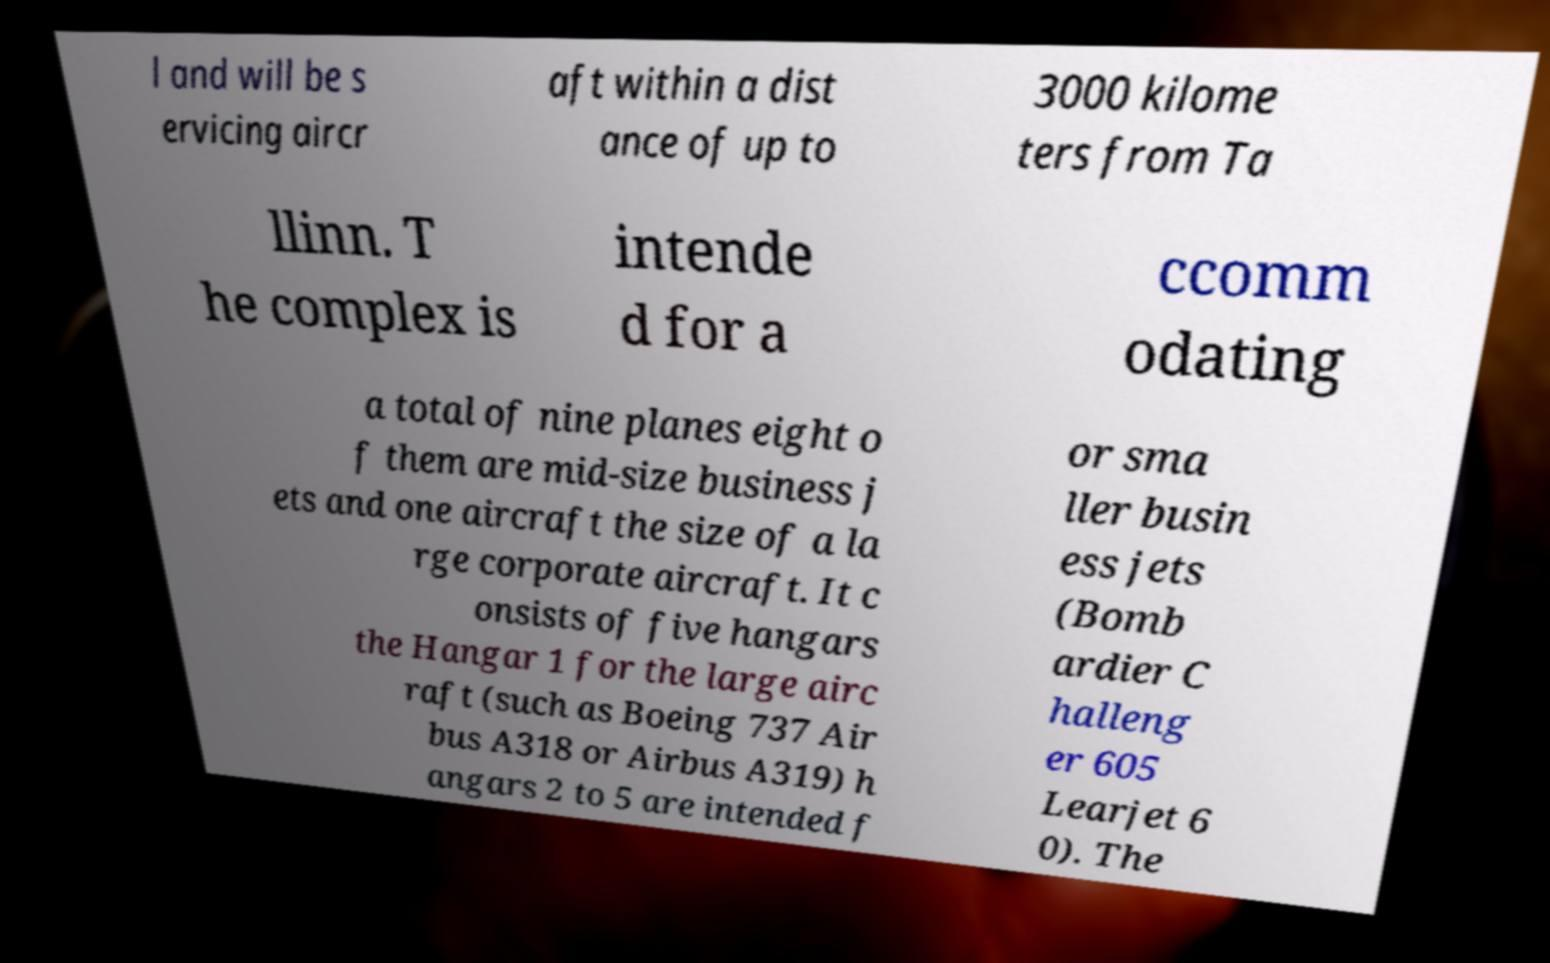Please read and relay the text visible in this image. What does it say? l and will be s ervicing aircr aft within a dist ance of up to 3000 kilome ters from Ta llinn. T he complex is intende d for a ccomm odating a total of nine planes eight o f them are mid-size business j ets and one aircraft the size of a la rge corporate aircraft. It c onsists of five hangars the Hangar 1 for the large airc raft (such as Boeing 737 Air bus A318 or Airbus A319) h angars 2 to 5 are intended f or sma ller busin ess jets (Bomb ardier C halleng er 605 Learjet 6 0). The 